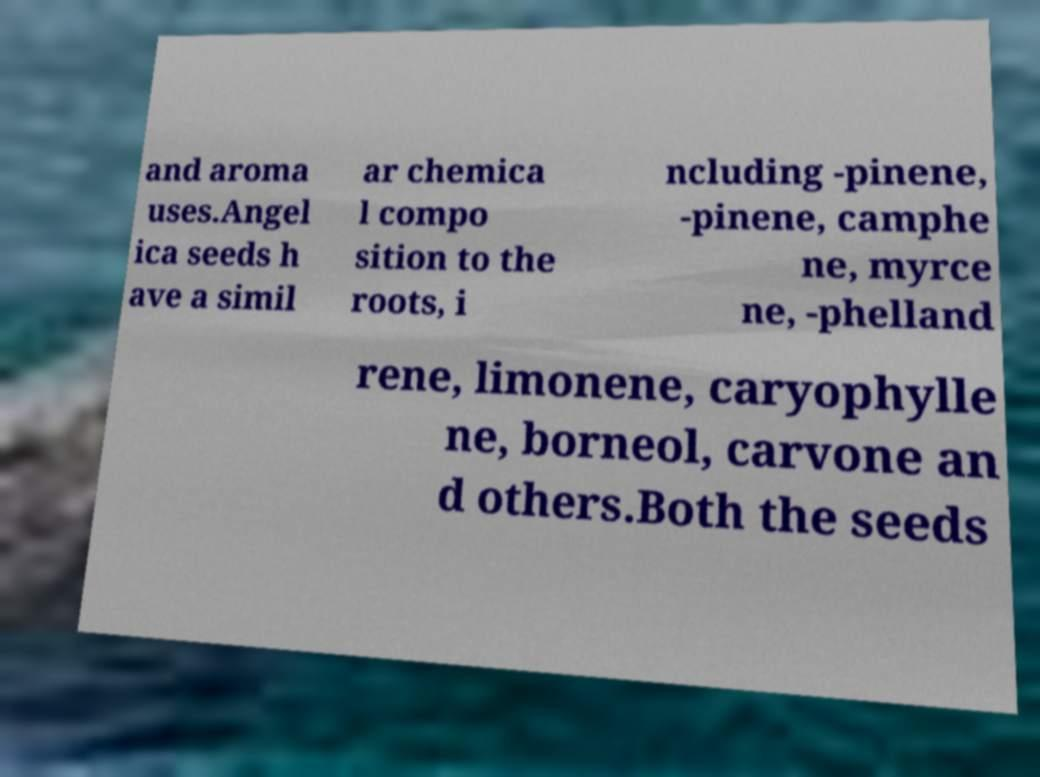What messages or text are displayed in this image? I need them in a readable, typed format. and aroma uses.Angel ica seeds h ave a simil ar chemica l compo sition to the roots, i ncluding -pinene, -pinene, camphe ne, myrce ne, -phelland rene, limonene, caryophylle ne, borneol, carvone an d others.Both the seeds 